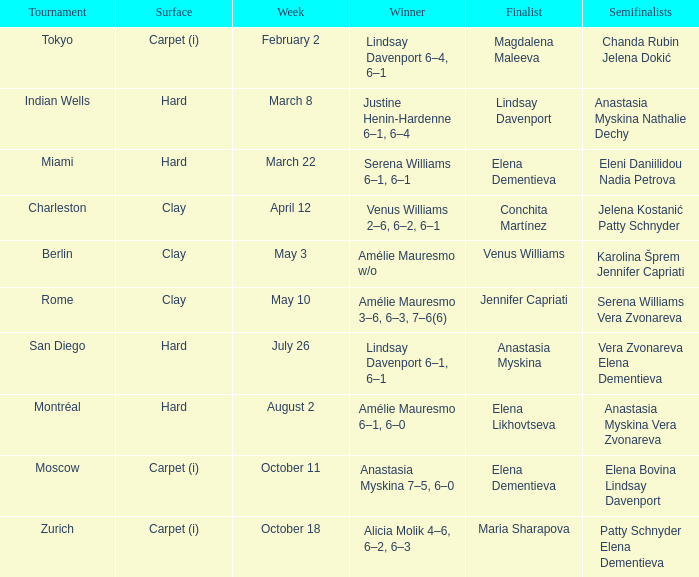Who was the finalist of the hard surface tournament in Miami? Elena Dementieva. 